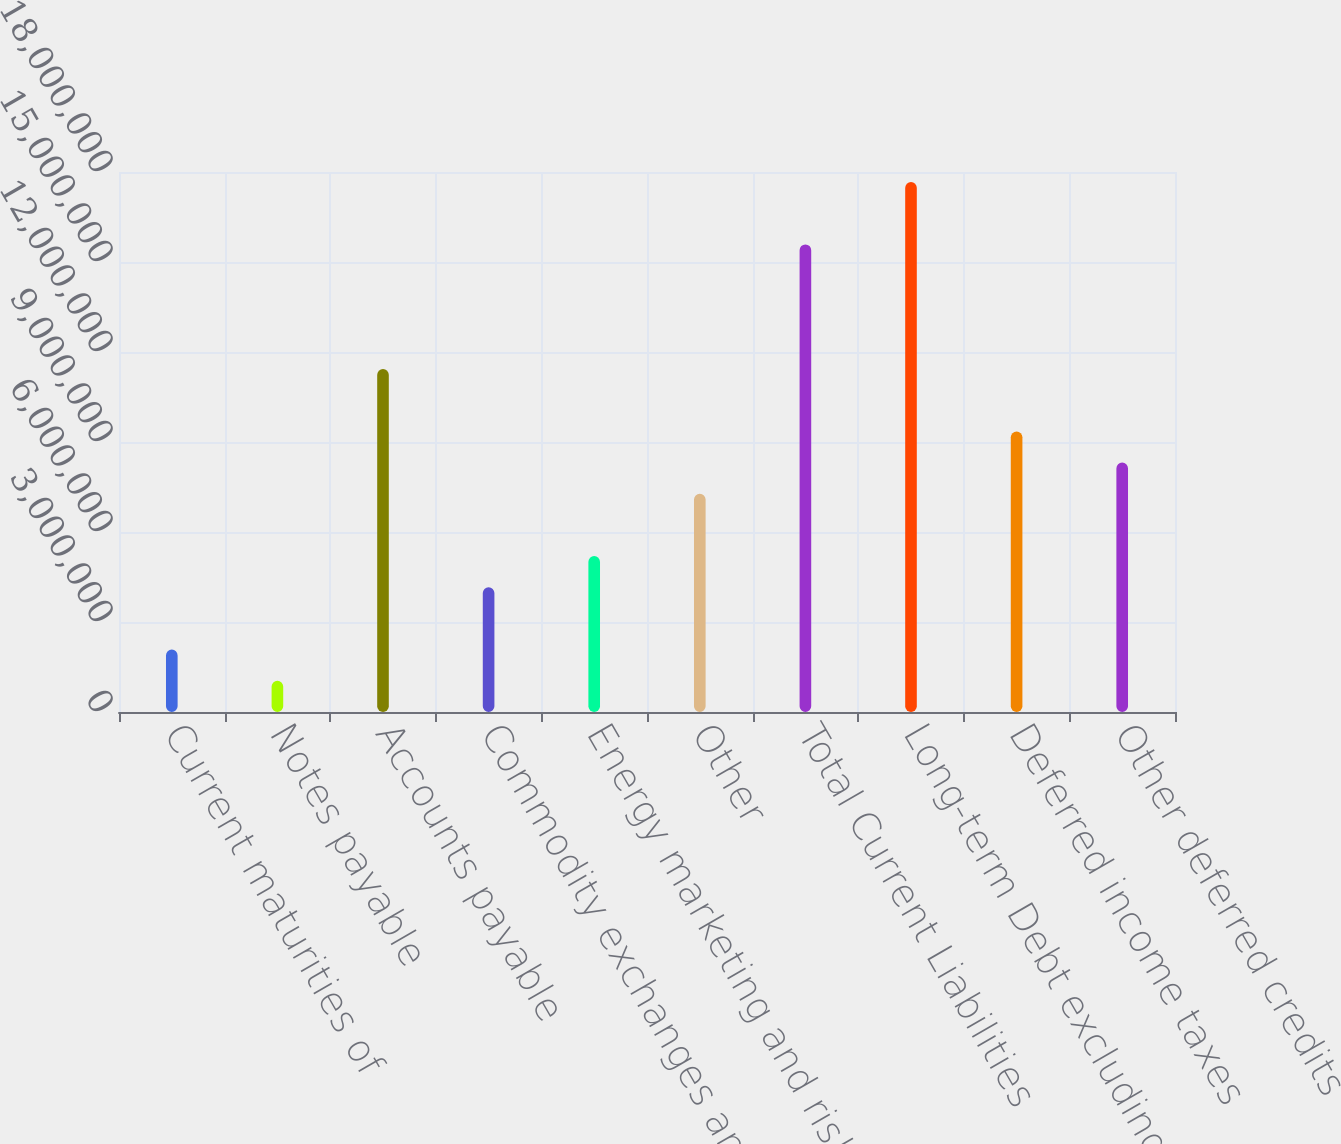<chart> <loc_0><loc_0><loc_500><loc_500><bar_chart><fcel>Current maturities of<fcel>Notes payable<fcel>Accounts payable<fcel>Commodity exchanges and<fcel>Energy marketing and risk<fcel>Other<fcel>Total Current Liabilities<fcel>Long-term Debt excluding<fcel>Deferred income taxes<fcel>Other deferred credits<nl><fcel>2.07918e+06<fcel>1.04019e+06<fcel>1.14301e+07<fcel>4.15715e+06<fcel>5.19614e+06<fcel>7.27412e+06<fcel>1.5586e+07<fcel>1.7664e+07<fcel>9.35209e+06<fcel>8.31311e+06<nl></chart> 